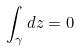Convert formula to latex. <formula><loc_0><loc_0><loc_500><loc_500>\int _ { \gamma } d z = 0</formula> 